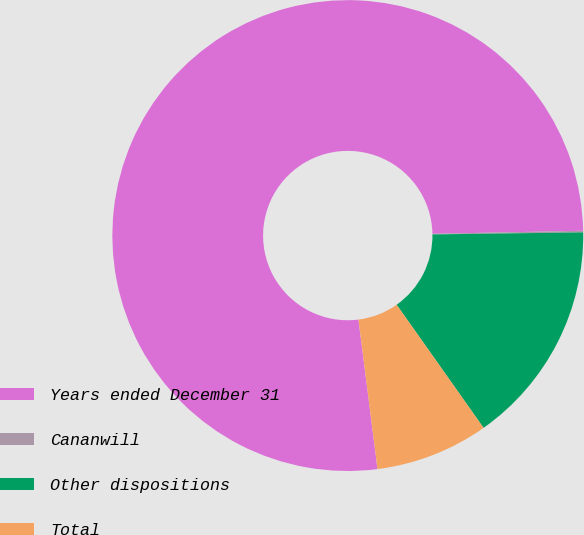Convert chart. <chart><loc_0><loc_0><loc_500><loc_500><pie_chart><fcel>Years ended December 31<fcel>Cananwill<fcel>Other dispositions<fcel>Total<nl><fcel>76.69%<fcel>0.11%<fcel>15.43%<fcel>7.77%<nl></chart> 